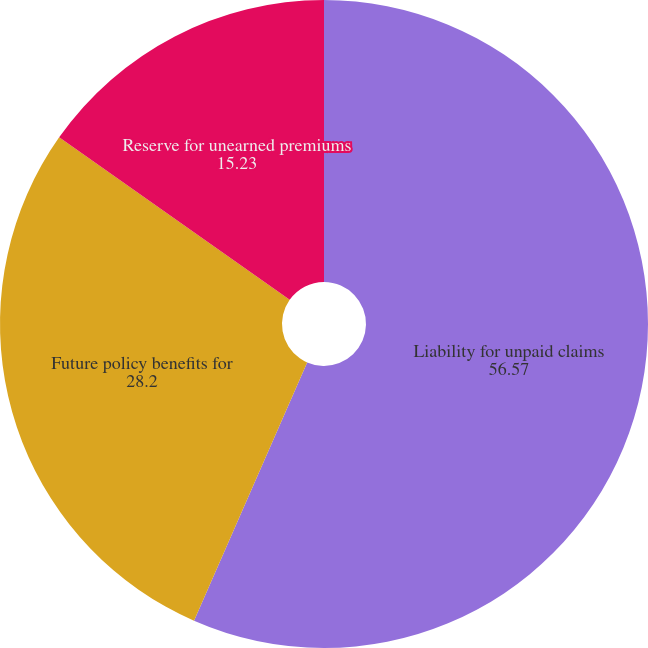<chart> <loc_0><loc_0><loc_500><loc_500><pie_chart><fcel>Liability for unpaid claims<fcel>Future policy benefits for<fcel>Reserve for unearned premiums<nl><fcel>56.57%<fcel>28.2%<fcel>15.23%<nl></chart> 